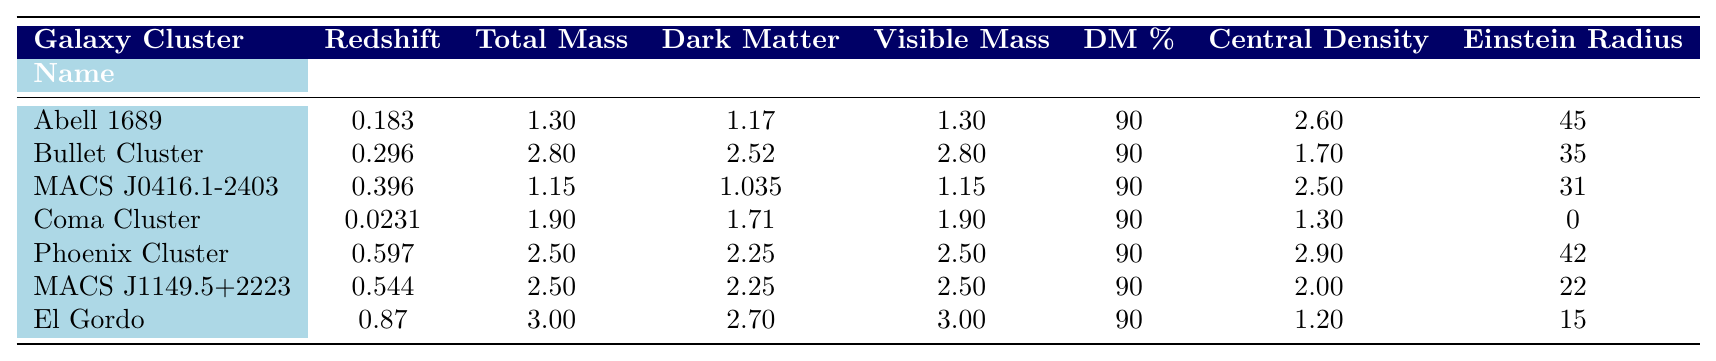What is the total mass of the Bullet Cluster? The table directly lists the total mass of the Bullet Cluster as 2.80 x 10^15 solar masses.
Answer: 2.80 x 10^15 Which galaxy cluster has the highest total mass? By comparing the total mass of each galaxy cluster in the table, the Bullet Cluster has the highest total mass at 2.80 x 10^15 solar masses.
Answer: Bullet Cluster What is the dark matter percentage of the MACS J0416.1-2403? The table shows that the dark matter percentage for MACS J0416.1-2403 is 90%.
Answer: 90% Calculate the average dark matter mass across all galaxy clusters. To find the average dark matter mass, sum the dark matter masses: (1.17 + 2.52 + 1.035 + 1.71 + 2.25 + 2.25 + 2.7) = 13.59. Then divide by the number of clusters (7): 13.59 / 7 = 1.94143 x 10^15 solar masses.
Answer: 1.94 x 10^15 What is the Einstein radius of the Coma Cluster? The table indicates that the Einstein radius of the Coma Cluster is 0 arcseconds.
Answer: 0 Is there a galaxy cluster with a redshift greater than 0.5? Yes, the Phoenix Cluster and El Gordo both have redshifts greater than 0.5, with values of 0.597 and 0.87 respectively.
Answer: Yes Which galaxy cluster has the lowest central density? By reviewing the central density values in the table, the El Gordo galaxy cluster has the lowest central density at 0.012 x 10^-2 g/cm^3.
Answer: El Gordo What is the difference in dark matter mass between the Phoenix Cluster and the MACS J1149.5+2223? The dark matter mass for the Phoenix Cluster is 2.25 x 10^15 solar masses, while for the MACS J1149.5+2223 it is also 2.25 x 10^15 solar masses. The difference is 2.25 - 2.25 = 0.
Answer: 0 What percentage of the total mass does dark matter constitute for the Coma Cluster? The table states that dark matter constitutes 90% of the total mass for the Coma Cluster, matching the values for the other clusters as well.
Answer: 90% Among these galaxy clusters, which has the largest dark matter percentage and what is that percentage? All galaxy clusters listed in the table have a dark matter percentage of 90%, making it the largest and only percentage value.
Answer: 90% 